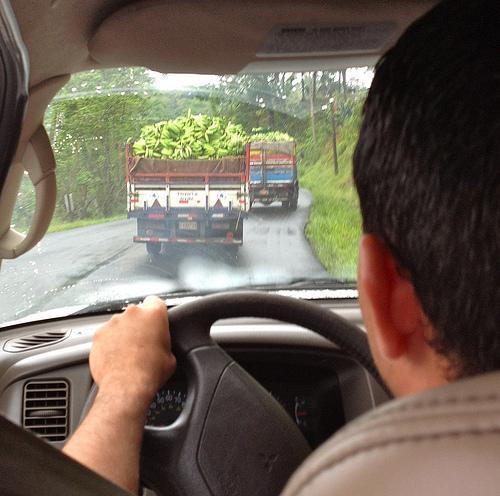How many trucks of bananas are there?
Give a very brief answer. 2. 